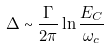Convert formula to latex. <formula><loc_0><loc_0><loc_500><loc_500>\Delta \sim \frac { \Gamma } { 2 \pi } \ln \frac { E _ { C } } { \omega _ { c } }</formula> 